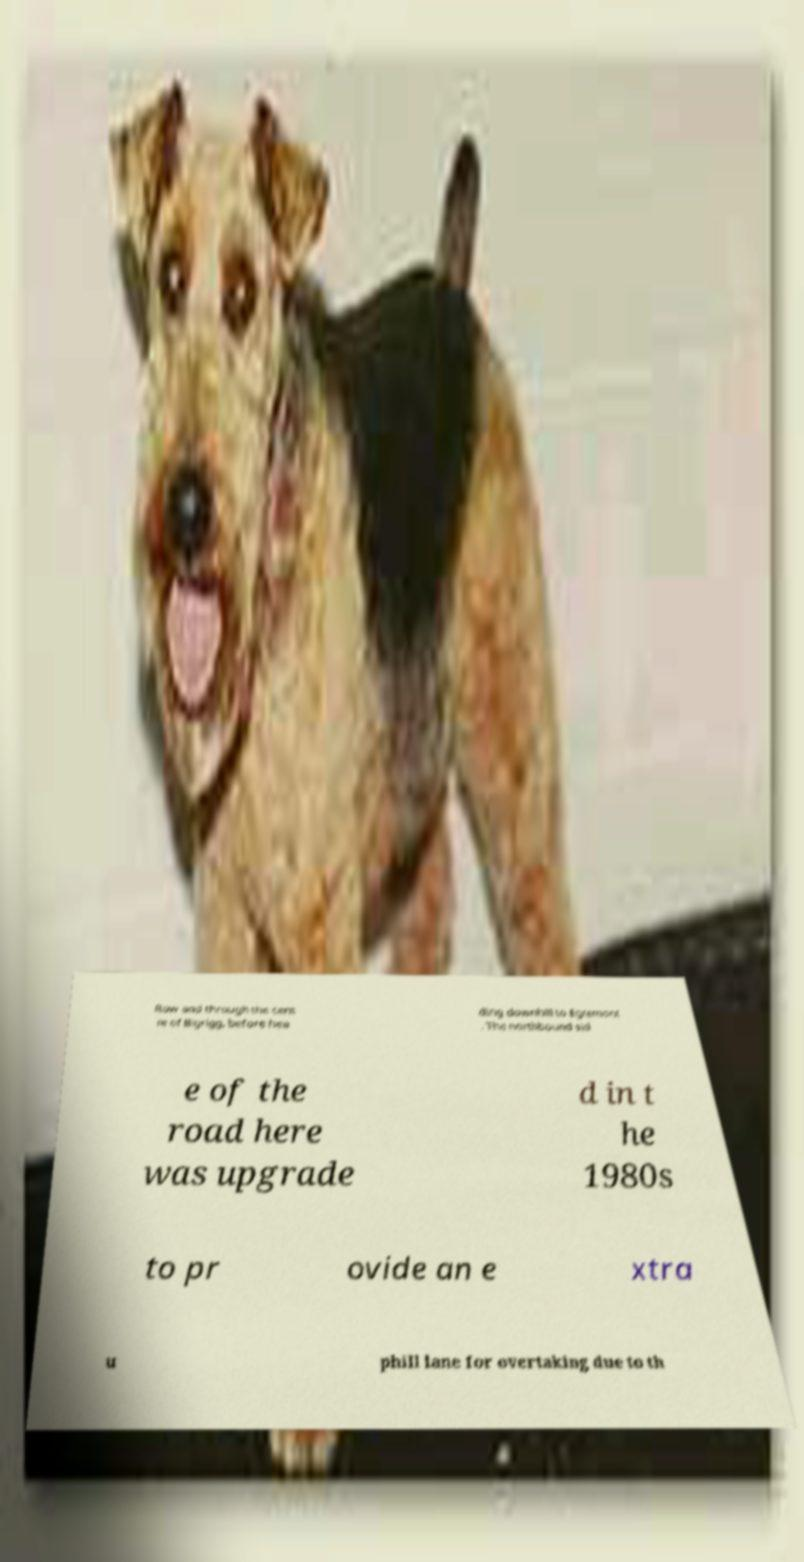For documentation purposes, I need the text within this image transcribed. Could you provide that? Row and through the cent re of Bigrigg, before hea ding downhill to Egremont . The northbound sid e of the road here was upgrade d in t he 1980s to pr ovide an e xtra u phill lane for overtaking due to th 